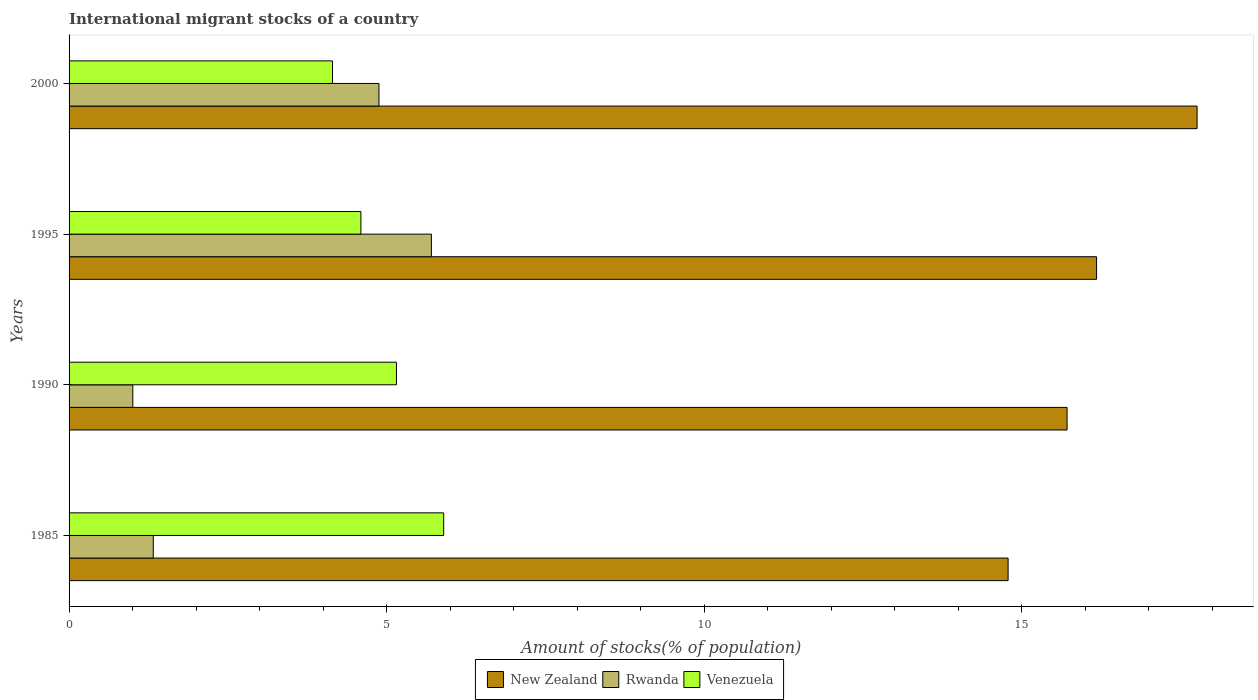How many different coloured bars are there?
Offer a terse response. 3. Are the number of bars on each tick of the Y-axis equal?
Your response must be concise. Yes. How many bars are there on the 3rd tick from the top?
Make the answer very short. 3. What is the label of the 1st group of bars from the top?
Offer a terse response. 2000. What is the amount of stocks in in Rwanda in 1995?
Make the answer very short. 5.7. Across all years, what is the maximum amount of stocks in in New Zealand?
Your answer should be compact. 17.76. Across all years, what is the minimum amount of stocks in in New Zealand?
Keep it short and to the point. 14.78. In which year was the amount of stocks in in Rwanda maximum?
Ensure brevity in your answer.  1995. In which year was the amount of stocks in in Rwanda minimum?
Make the answer very short. 1990. What is the total amount of stocks in in Venezuela in the graph?
Ensure brevity in your answer.  19.79. What is the difference between the amount of stocks in in Rwanda in 1985 and that in 2000?
Offer a very short reply. -3.55. What is the difference between the amount of stocks in in Venezuela in 2000 and the amount of stocks in in New Zealand in 1995?
Make the answer very short. -12.03. What is the average amount of stocks in in Venezuela per year?
Keep it short and to the point. 4.95. In the year 1995, what is the difference between the amount of stocks in in Venezuela and amount of stocks in in Rwanda?
Your answer should be compact. -1.11. What is the ratio of the amount of stocks in in Venezuela in 1990 to that in 2000?
Make the answer very short. 1.24. Is the difference between the amount of stocks in in Venezuela in 1990 and 1995 greater than the difference between the amount of stocks in in Rwanda in 1990 and 1995?
Your answer should be very brief. Yes. What is the difference between the highest and the second highest amount of stocks in in Rwanda?
Ensure brevity in your answer.  0.83. What is the difference between the highest and the lowest amount of stocks in in Rwanda?
Ensure brevity in your answer.  4.7. What does the 1st bar from the top in 1990 represents?
Keep it short and to the point. Venezuela. What does the 3rd bar from the bottom in 2000 represents?
Keep it short and to the point. Venezuela. Is it the case that in every year, the sum of the amount of stocks in in New Zealand and amount of stocks in in Venezuela is greater than the amount of stocks in in Rwanda?
Your response must be concise. Yes. How many years are there in the graph?
Provide a succinct answer. 4. What is the difference between two consecutive major ticks on the X-axis?
Provide a succinct answer. 5. Does the graph contain any zero values?
Provide a short and direct response. No. Where does the legend appear in the graph?
Keep it short and to the point. Bottom center. What is the title of the graph?
Make the answer very short. International migrant stocks of a country. Does "Portugal" appear as one of the legend labels in the graph?
Ensure brevity in your answer.  No. What is the label or title of the X-axis?
Offer a terse response. Amount of stocks(% of population). What is the Amount of stocks(% of population) in New Zealand in 1985?
Keep it short and to the point. 14.78. What is the Amount of stocks(% of population) in Rwanda in 1985?
Offer a terse response. 1.33. What is the Amount of stocks(% of population) of Venezuela in 1985?
Offer a very short reply. 5.9. What is the Amount of stocks(% of population) of New Zealand in 1990?
Provide a short and direct response. 15.71. What is the Amount of stocks(% of population) of Rwanda in 1990?
Offer a terse response. 1. What is the Amount of stocks(% of population) of Venezuela in 1990?
Ensure brevity in your answer.  5.15. What is the Amount of stocks(% of population) in New Zealand in 1995?
Make the answer very short. 16.18. What is the Amount of stocks(% of population) in Rwanda in 1995?
Ensure brevity in your answer.  5.7. What is the Amount of stocks(% of population) in Venezuela in 1995?
Your answer should be very brief. 4.59. What is the Amount of stocks(% of population) of New Zealand in 2000?
Make the answer very short. 17.76. What is the Amount of stocks(% of population) in Rwanda in 2000?
Your answer should be compact. 4.88. What is the Amount of stocks(% of population) of Venezuela in 2000?
Make the answer very short. 4.15. Across all years, what is the maximum Amount of stocks(% of population) of New Zealand?
Provide a short and direct response. 17.76. Across all years, what is the maximum Amount of stocks(% of population) of Rwanda?
Your answer should be very brief. 5.7. Across all years, what is the maximum Amount of stocks(% of population) in Venezuela?
Make the answer very short. 5.9. Across all years, what is the minimum Amount of stocks(% of population) in New Zealand?
Provide a succinct answer. 14.78. Across all years, what is the minimum Amount of stocks(% of population) in Rwanda?
Provide a short and direct response. 1. Across all years, what is the minimum Amount of stocks(% of population) of Venezuela?
Offer a very short reply. 4.15. What is the total Amount of stocks(% of population) of New Zealand in the graph?
Provide a succinct answer. 64.43. What is the total Amount of stocks(% of population) of Rwanda in the graph?
Your answer should be compact. 12.91. What is the total Amount of stocks(% of population) in Venezuela in the graph?
Make the answer very short. 19.79. What is the difference between the Amount of stocks(% of population) of New Zealand in 1985 and that in 1990?
Your response must be concise. -0.93. What is the difference between the Amount of stocks(% of population) in Rwanda in 1985 and that in 1990?
Make the answer very short. 0.32. What is the difference between the Amount of stocks(% of population) in Venezuela in 1985 and that in 1990?
Your answer should be very brief. 0.74. What is the difference between the Amount of stocks(% of population) in New Zealand in 1985 and that in 1995?
Offer a terse response. -1.39. What is the difference between the Amount of stocks(% of population) of Rwanda in 1985 and that in 1995?
Give a very brief answer. -4.38. What is the difference between the Amount of stocks(% of population) in Venezuela in 1985 and that in 1995?
Your answer should be very brief. 1.3. What is the difference between the Amount of stocks(% of population) of New Zealand in 1985 and that in 2000?
Ensure brevity in your answer.  -2.98. What is the difference between the Amount of stocks(% of population) of Rwanda in 1985 and that in 2000?
Make the answer very short. -3.55. What is the difference between the Amount of stocks(% of population) in Venezuela in 1985 and that in 2000?
Offer a terse response. 1.75. What is the difference between the Amount of stocks(% of population) in New Zealand in 1990 and that in 1995?
Offer a very short reply. -0.46. What is the difference between the Amount of stocks(% of population) in Rwanda in 1990 and that in 1995?
Make the answer very short. -4.7. What is the difference between the Amount of stocks(% of population) of Venezuela in 1990 and that in 1995?
Offer a terse response. 0.56. What is the difference between the Amount of stocks(% of population) of New Zealand in 1990 and that in 2000?
Ensure brevity in your answer.  -2.05. What is the difference between the Amount of stocks(% of population) of Rwanda in 1990 and that in 2000?
Offer a terse response. -3.88. What is the difference between the Amount of stocks(% of population) in New Zealand in 1995 and that in 2000?
Provide a short and direct response. -1.58. What is the difference between the Amount of stocks(% of population) of Rwanda in 1995 and that in 2000?
Your answer should be compact. 0.83. What is the difference between the Amount of stocks(% of population) of Venezuela in 1995 and that in 2000?
Keep it short and to the point. 0.45. What is the difference between the Amount of stocks(% of population) of New Zealand in 1985 and the Amount of stocks(% of population) of Rwanda in 1990?
Your answer should be compact. 13.78. What is the difference between the Amount of stocks(% of population) in New Zealand in 1985 and the Amount of stocks(% of population) in Venezuela in 1990?
Your answer should be very brief. 9.63. What is the difference between the Amount of stocks(% of population) of Rwanda in 1985 and the Amount of stocks(% of population) of Venezuela in 1990?
Give a very brief answer. -3.83. What is the difference between the Amount of stocks(% of population) in New Zealand in 1985 and the Amount of stocks(% of population) in Rwanda in 1995?
Your response must be concise. 9.08. What is the difference between the Amount of stocks(% of population) of New Zealand in 1985 and the Amount of stocks(% of population) of Venezuela in 1995?
Provide a short and direct response. 10.19. What is the difference between the Amount of stocks(% of population) in Rwanda in 1985 and the Amount of stocks(% of population) in Venezuela in 1995?
Your response must be concise. -3.27. What is the difference between the Amount of stocks(% of population) of New Zealand in 1985 and the Amount of stocks(% of population) of Rwanda in 2000?
Make the answer very short. 9.9. What is the difference between the Amount of stocks(% of population) of New Zealand in 1985 and the Amount of stocks(% of population) of Venezuela in 2000?
Offer a very short reply. 10.64. What is the difference between the Amount of stocks(% of population) in Rwanda in 1985 and the Amount of stocks(% of population) in Venezuela in 2000?
Offer a terse response. -2.82. What is the difference between the Amount of stocks(% of population) of New Zealand in 1990 and the Amount of stocks(% of population) of Rwanda in 1995?
Give a very brief answer. 10.01. What is the difference between the Amount of stocks(% of population) in New Zealand in 1990 and the Amount of stocks(% of population) in Venezuela in 1995?
Your answer should be very brief. 11.12. What is the difference between the Amount of stocks(% of population) of Rwanda in 1990 and the Amount of stocks(% of population) of Venezuela in 1995?
Your answer should be very brief. -3.59. What is the difference between the Amount of stocks(% of population) in New Zealand in 1990 and the Amount of stocks(% of population) in Rwanda in 2000?
Offer a terse response. 10.83. What is the difference between the Amount of stocks(% of population) in New Zealand in 1990 and the Amount of stocks(% of population) in Venezuela in 2000?
Your answer should be compact. 11.56. What is the difference between the Amount of stocks(% of population) in Rwanda in 1990 and the Amount of stocks(% of population) in Venezuela in 2000?
Your response must be concise. -3.14. What is the difference between the Amount of stocks(% of population) of New Zealand in 1995 and the Amount of stocks(% of population) of Rwanda in 2000?
Ensure brevity in your answer.  11.3. What is the difference between the Amount of stocks(% of population) of New Zealand in 1995 and the Amount of stocks(% of population) of Venezuela in 2000?
Ensure brevity in your answer.  12.03. What is the difference between the Amount of stocks(% of population) in Rwanda in 1995 and the Amount of stocks(% of population) in Venezuela in 2000?
Offer a very short reply. 1.56. What is the average Amount of stocks(% of population) of New Zealand per year?
Offer a very short reply. 16.11. What is the average Amount of stocks(% of population) in Rwanda per year?
Your answer should be compact. 3.23. What is the average Amount of stocks(% of population) in Venezuela per year?
Offer a very short reply. 4.95. In the year 1985, what is the difference between the Amount of stocks(% of population) of New Zealand and Amount of stocks(% of population) of Rwanda?
Offer a terse response. 13.46. In the year 1985, what is the difference between the Amount of stocks(% of population) of New Zealand and Amount of stocks(% of population) of Venezuela?
Provide a short and direct response. 8.89. In the year 1985, what is the difference between the Amount of stocks(% of population) in Rwanda and Amount of stocks(% of population) in Venezuela?
Make the answer very short. -4.57. In the year 1990, what is the difference between the Amount of stocks(% of population) in New Zealand and Amount of stocks(% of population) in Rwanda?
Make the answer very short. 14.71. In the year 1990, what is the difference between the Amount of stocks(% of population) of New Zealand and Amount of stocks(% of population) of Venezuela?
Your answer should be very brief. 10.56. In the year 1990, what is the difference between the Amount of stocks(% of population) in Rwanda and Amount of stocks(% of population) in Venezuela?
Offer a very short reply. -4.15. In the year 1995, what is the difference between the Amount of stocks(% of population) of New Zealand and Amount of stocks(% of population) of Rwanda?
Your answer should be very brief. 10.47. In the year 1995, what is the difference between the Amount of stocks(% of population) in New Zealand and Amount of stocks(% of population) in Venezuela?
Give a very brief answer. 11.58. In the year 1995, what is the difference between the Amount of stocks(% of population) in Rwanda and Amount of stocks(% of population) in Venezuela?
Your response must be concise. 1.11. In the year 2000, what is the difference between the Amount of stocks(% of population) in New Zealand and Amount of stocks(% of population) in Rwanda?
Give a very brief answer. 12.88. In the year 2000, what is the difference between the Amount of stocks(% of population) in New Zealand and Amount of stocks(% of population) in Venezuela?
Your response must be concise. 13.61. In the year 2000, what is the difference between the Amount of stocks(% of population) in Rwanda and Amount of stocks(% of population) in Venezuela?
Offer a very short reply. 0.73. What is the ratio of the Amount of stocks(% of population) in New Zealand in 1985 to that in 1990?
Keep it short and to the point. 0.94. What is the ratio of the Amount of stocks(% of population) of Rwanda in 1985 to that in 1990?
Provide a short and direct response. 1.32. What is the ratio of the Amount of stocks(% of population) in Venezuela in 1985 to that in 1990?
Your response must be concise. 1.14. What is the ratio of the Amount of stocks(% of population) of New Zealand in 1985 to that in 1995?
Your response must be concise. 0.91. What is the ratio of the Amount of stocks(% of population) in Rwanda in 1985 to that in 1995?
Offer a terse response. 0.23. What is the ratio of the Amount of stocks(% of population) of Venezuela in 1985 to that in 1995?
Offer a very short reply. 1.28. What is the ratio of the Amount of stocks(% of population) of New Zealand in 1985 to that in 2000?
Make the answer very short. 0.83. What is the ratio of the Amount of stocks(% of population) in Rwanda in 1985 to that in 2000?
Offer a terse response. 0.27. What is the ratio of the Amount of stocks(% of population) in Venezuela in 1985 to that in 2000?
Give a very brief answer. 1.42. What is the ratio of the Amount of stocks(% of population) of New Zealand in 1990 to that in 1995?
Give a very brief answer. 0.97. What is the ratio of the Amount of stocks(% of population) of Rwanda in 1990 to that in 1995?
Provide a succinct answer. 0.18. What is the ratio of the Amount of stocks(% of population) of Venezuela in 1990 to that in 1995?
Keep it short and to the point. 1.12. What is the ratio of the Amount of stocks(% of population) in New Zealand in 1990 to that in 2000?
Ensure brevity in your answer.  0.88. What is the ratio of the Amount of stocks(% of population) of Rwanda in 1990 to that in 2000?
Offer a terse response. 0.21. What is the ratio of the Amount of stocks(% of population) of Venezuela in 1990 to that in 2000?
Your response must be concise. 1.24. What is the ratio of the Amount of stocks(% of population) of New Zealand in 1995 to that in 2000?
Ensure brevity in your answer.  0.91. What is the ratio of the Amount of stocks(% of population) of Rwanda in 1995 to that in 2000?
Your answer should be very brief. 1.17. What is the ratio of the Amount of stocks(% of population) in Venezuela in 1995 to that in 2000?
Provide a short and direct response. 1.11. What is the difference between the highest and the second highest Amount of stocks(% of population) in New Zealand?
Keep it short and to the point. 1.58. What is the difference between the highest and the second highest Amount of stocks(% of population) in Rwanda?
Provide a short and direct response. 0.83. What is the difference between the highest and the second highest Amount of stocks(% of population) of Venezuela?
Ensure brevity in your answer.  0.74. What is the difference between the highest and the lowest Amount of stocks(% of population) of New Zealand?
Your answer should be very brief. 2.98. What is the difference between the highest and the lowest Amount of stocks(% of population) of Rwanda?
Your answer should be compact. 4.7. What is the difference between the highest and the lowest Amount of stocks(% of population) in Venezuela?
Give a very brief answer. 1.75. 